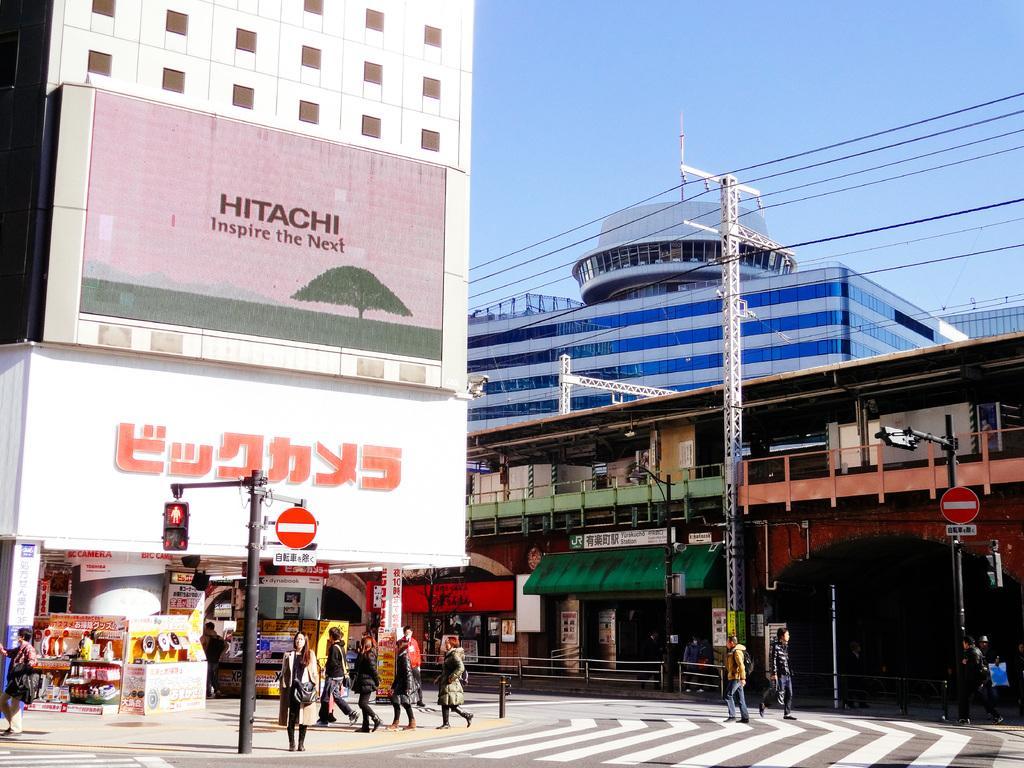In one or two sentences, can you explain what this image depicts? In this picture we can see people on the ground, here we can see poles, boards, buildings and some objects and we can see sky in the background. 